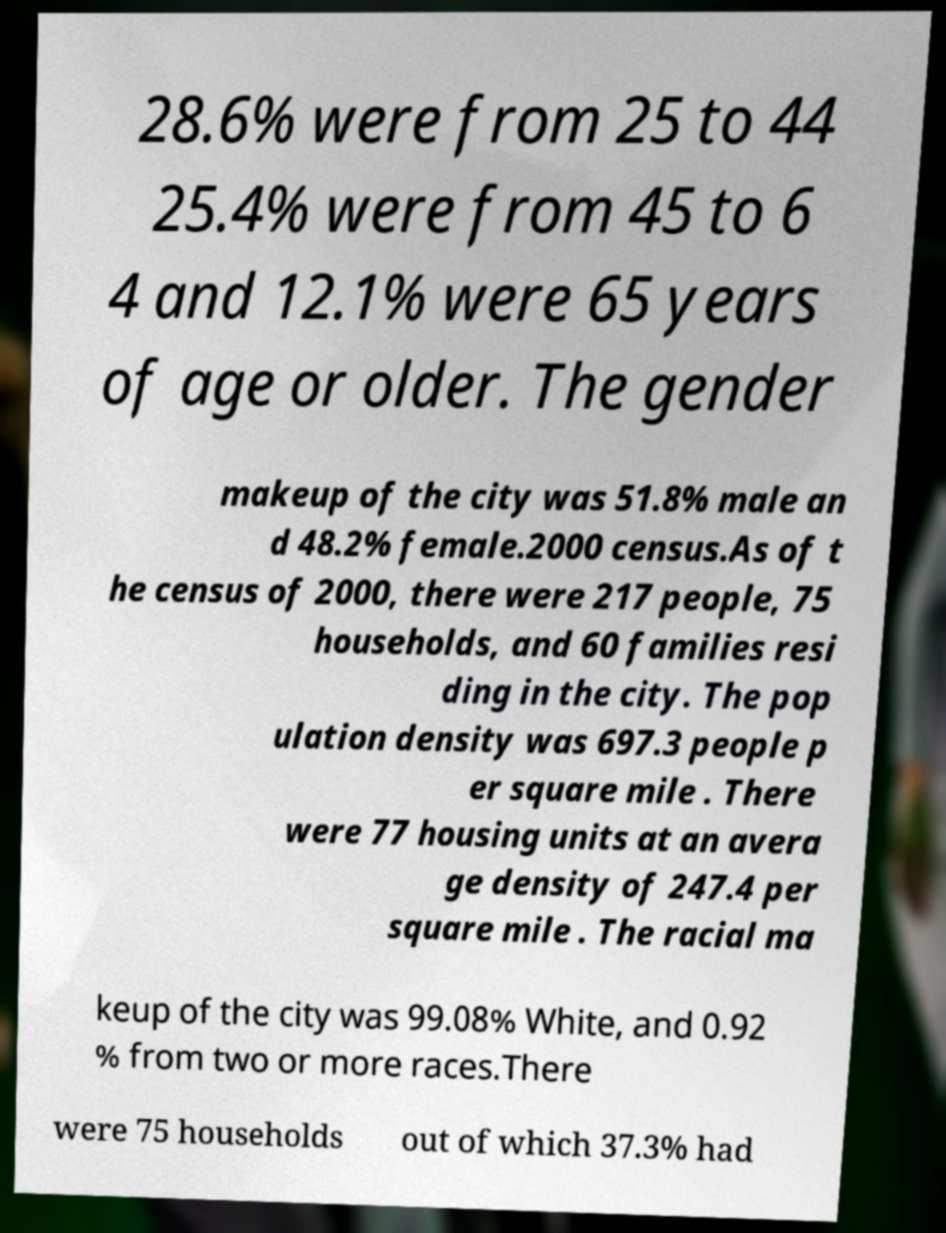Please identify and transcribe the text found in this image. 28.6% were from 25 to 44 25.4% were from 45 to 6 4 and 12.1% were 65 years of age or older. The gender makeup of the city was 51.8% male an d 48.2% female.2000 census.As of t he census of 2000, there were 217 people, 75 households, and 60 families resi ding in the city. The pop ulation density was 697.3 people p er square mile . There were 77 housing units at an avera ge density of 247.4 per square mile . The racial ma keup of the city was 99.08% White, and 0.92 % from two or more races.There were 75 households out of which 37.3% had 